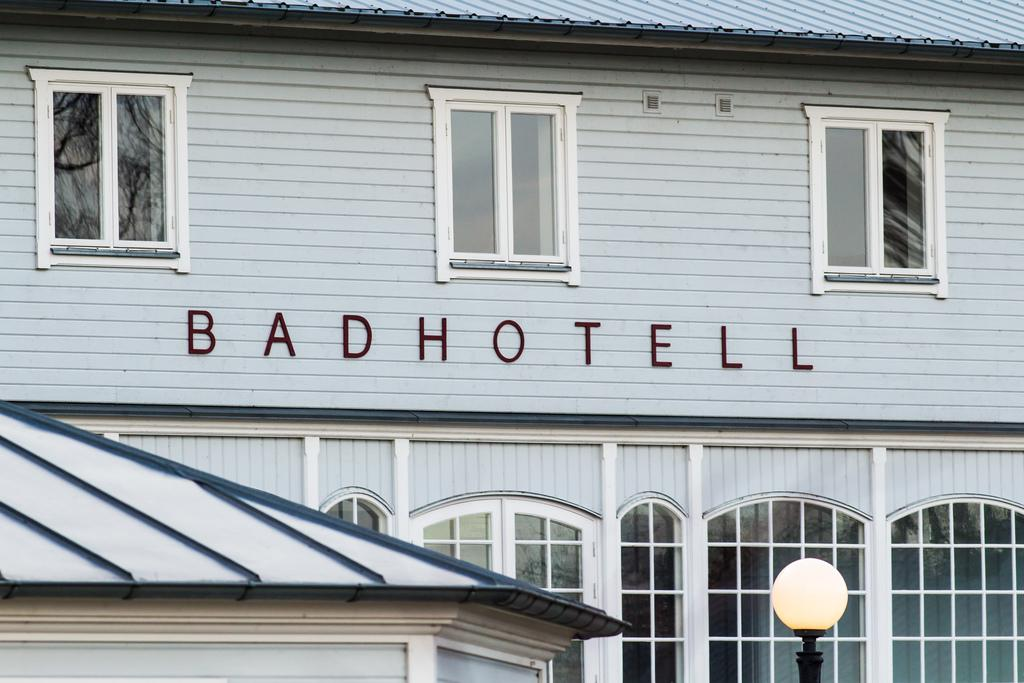Where was the picture taken? The picture was clicked outside. What is located in the foreground of the image? There is a lamppost and buildings in the foreground. What part of the buildings can be seen in the image? The windows of the buildings are visible. Is there any text present in the image? Yes, there is text on the wall of the building. Reasoning: Let'g: Let's think step by step in order to produce the conversation. We start by identifying the location of the image, which is outside. Then, we describe the main subjects in the foreground, which are a lamppost and buildings. Next, we focus on specific details of the buildings, such as their windows. Finally, we mention the presence of text on the wall of the building. Absurd Question/Answer: How many horses are visible in the image? There are no horses present in the image. What type of chairs can be seen in the image? There are no chairs visible in the image. 